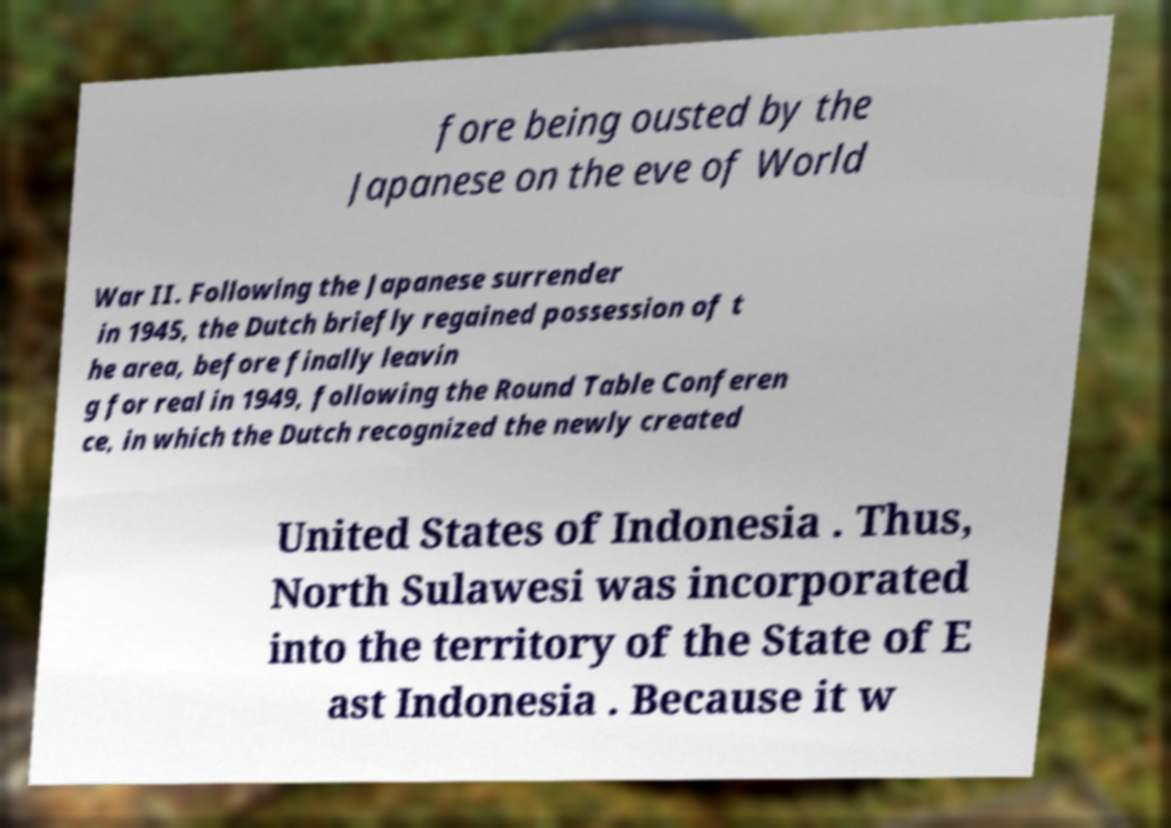Please identify and transcribe the text found in this image. fore being ousted by the Japanese on the eve of World War II. Following the Japanese surrender in 1945, the Dutch briefly regained possession of t he area, before finally leavin g for real in 1949, following the Round Table Conferen ce, in which the Dutch recognized the newly created United States of Indonesia . Thus, North Sulawesi was incorporated into the territory of the State of E ast Indonesia . Because it w 